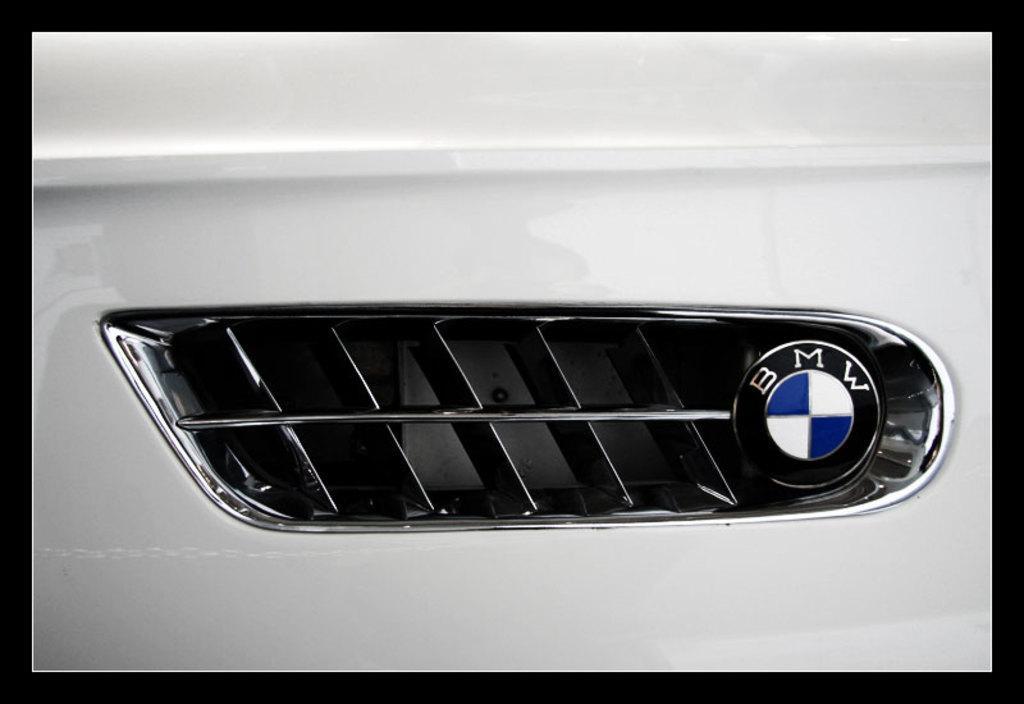Please provide a concise description of this image. In this picture I can see there is a side grill of a car and there is a logo and something written on the logo. There is a white and blue color logo. 